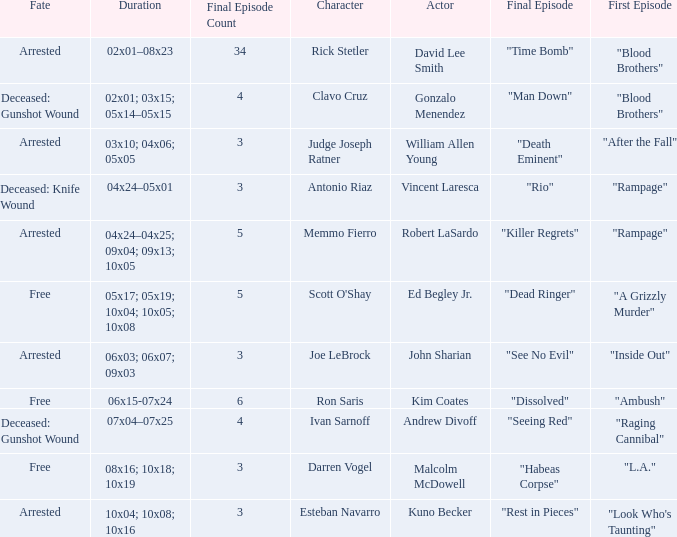What's the actor with character being judge joseph ratner William Allen Young. 